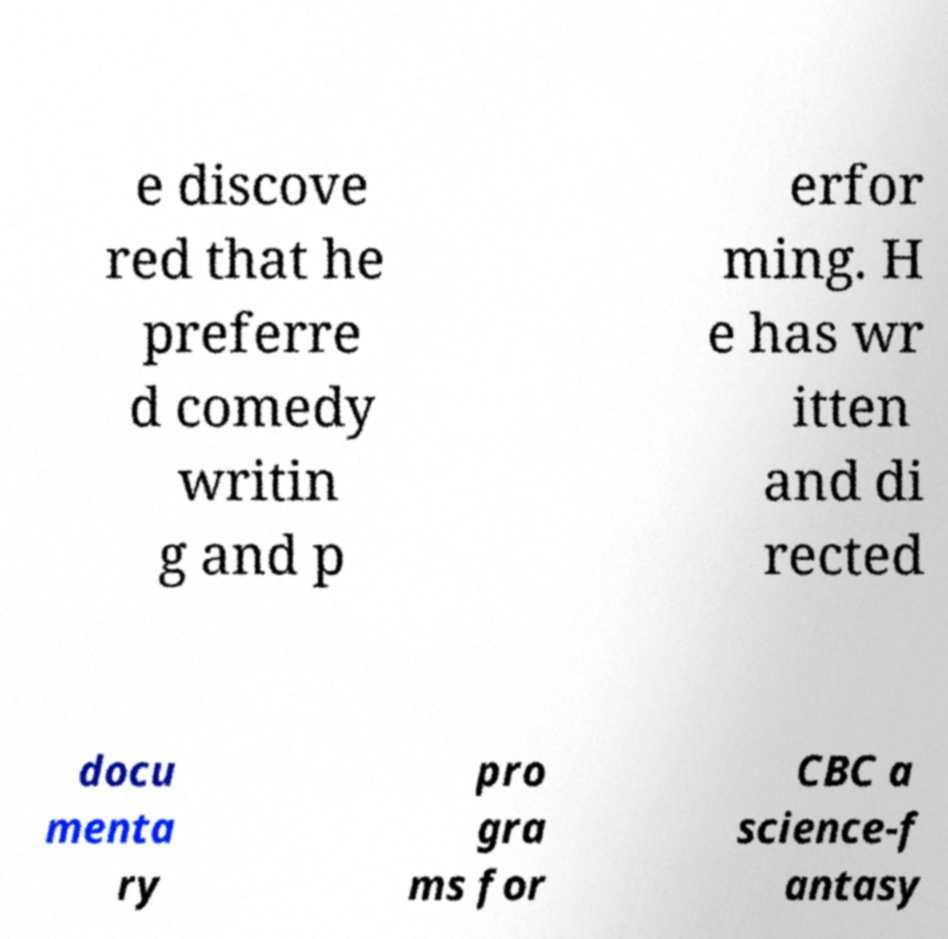Can you read and provide the text displayed in the image?This photo seems to have some interesting text. Can you extract and type it out for me? e discove red that he preferre d comedy writin g and p erfor ming. H e has wr itten and di rected docu menta ry pro gra ms for CBC a science-f antasy 